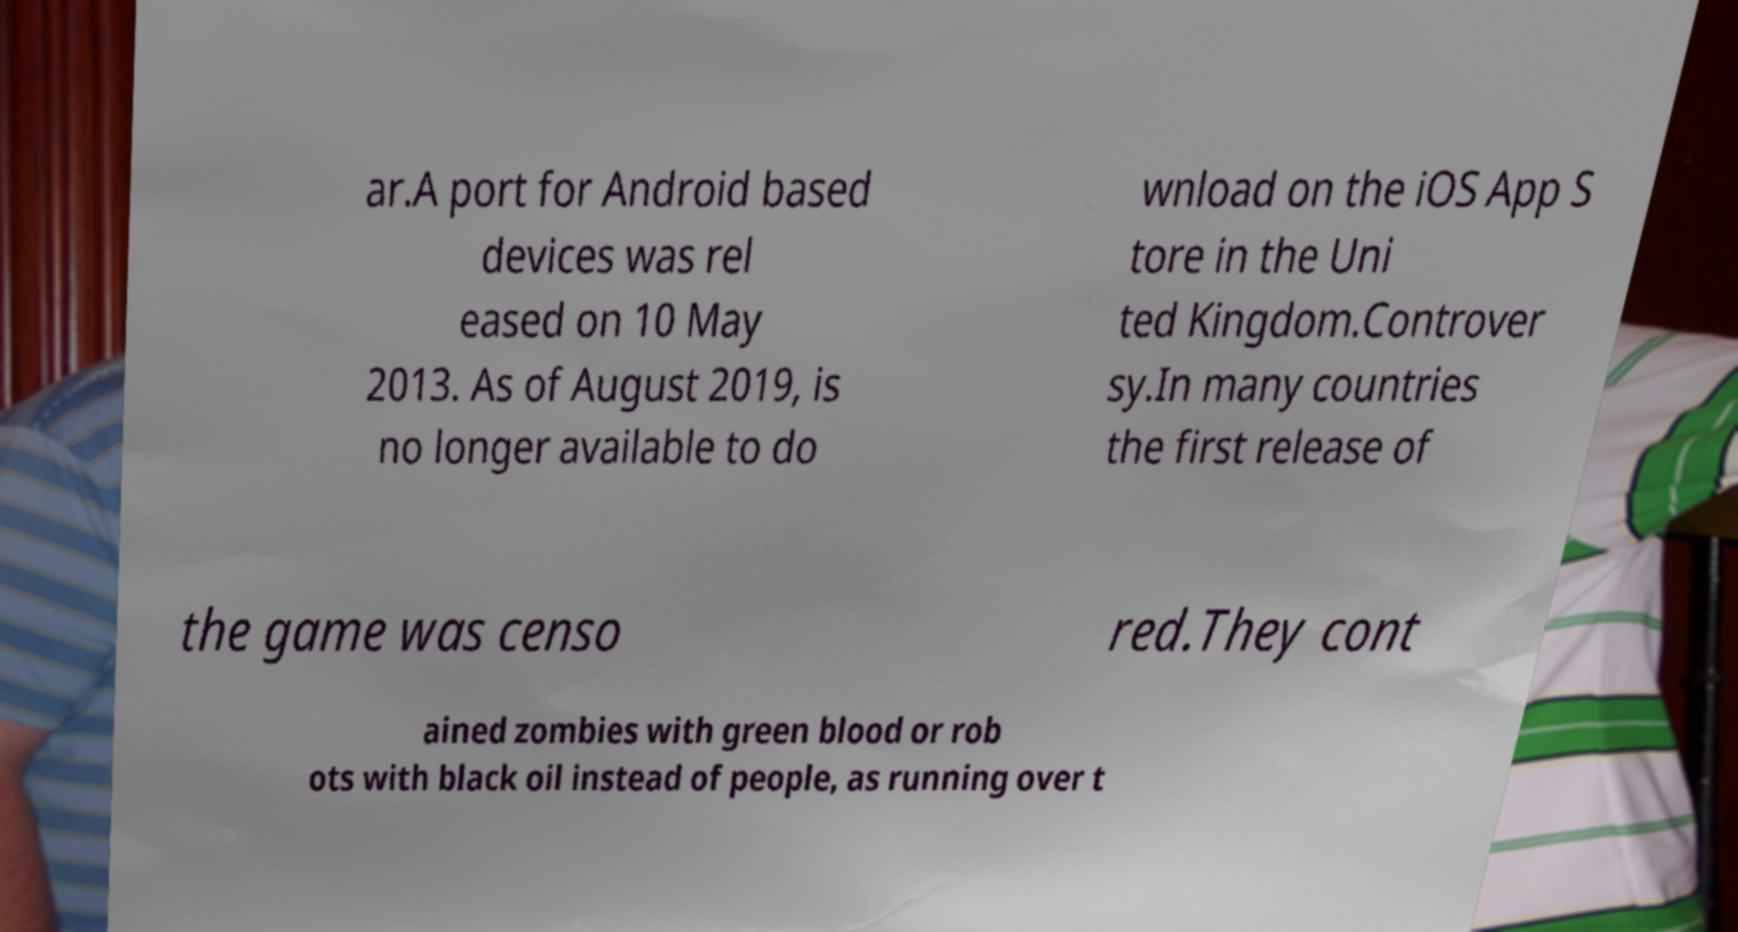What messages or text are displayed in this image? I need them in a readable, typed format. ar.A port for Android based devices was rel eased on 10 May 2013. As of August 2019, is no longer available to do wnload on the iOS App S tore in the Uni ted Kingdom.Controver sy.In many countries the first release of the game was censo red.They cont ained zombies with green blood or rob ots with black oil instead of people, as running over t 